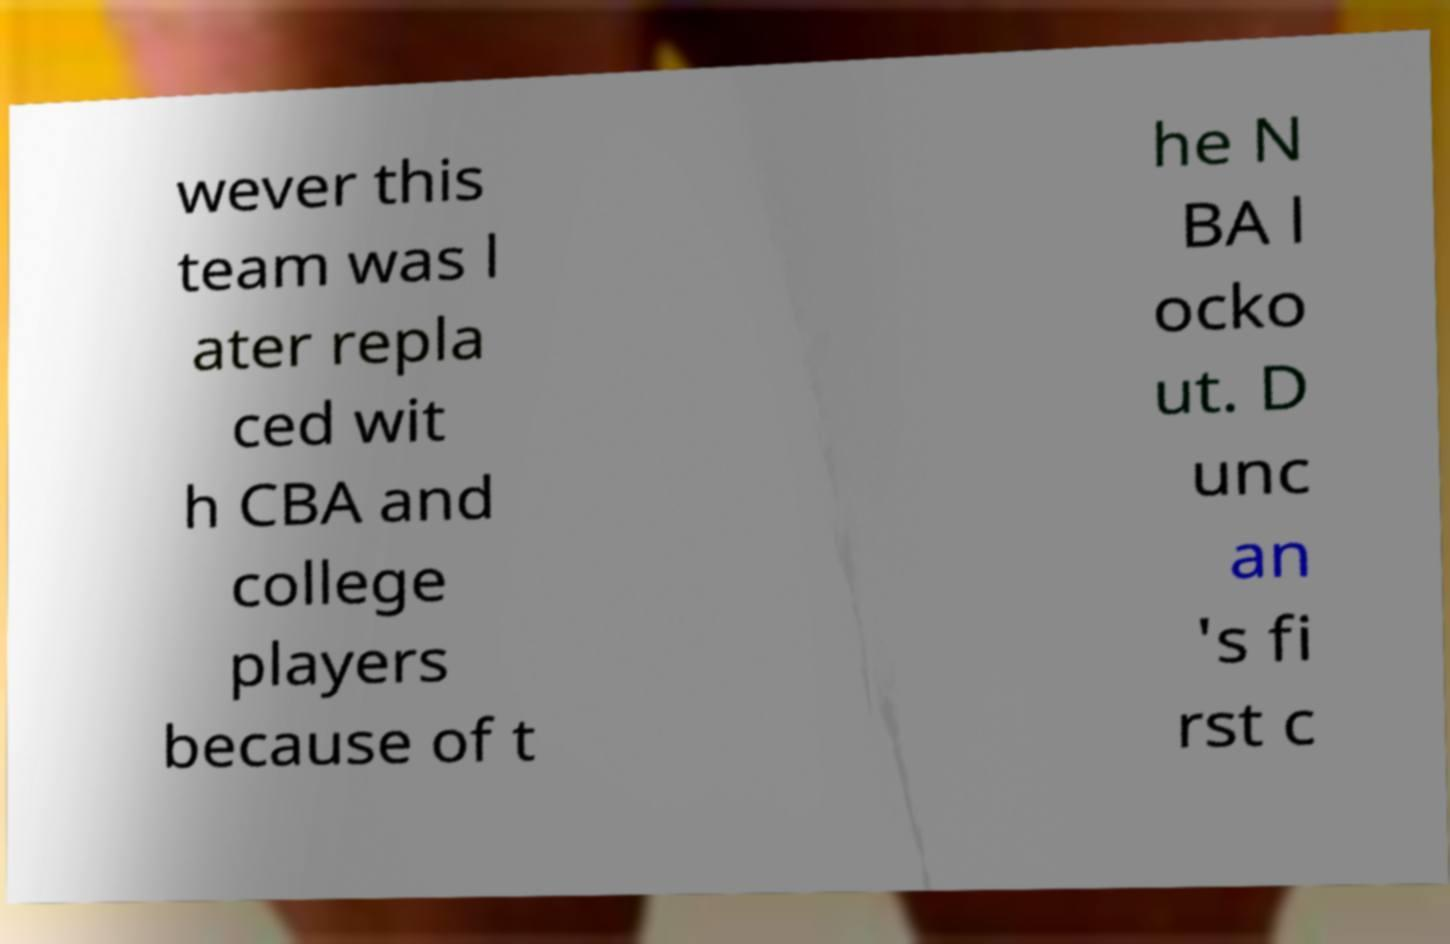What messages or text are displayed in this image? I need them in a readable, typed format. wever this team was l ater repla ced wit h CBA and college players because of t he N BA l ocko ut. D unc an 's fi rst c 